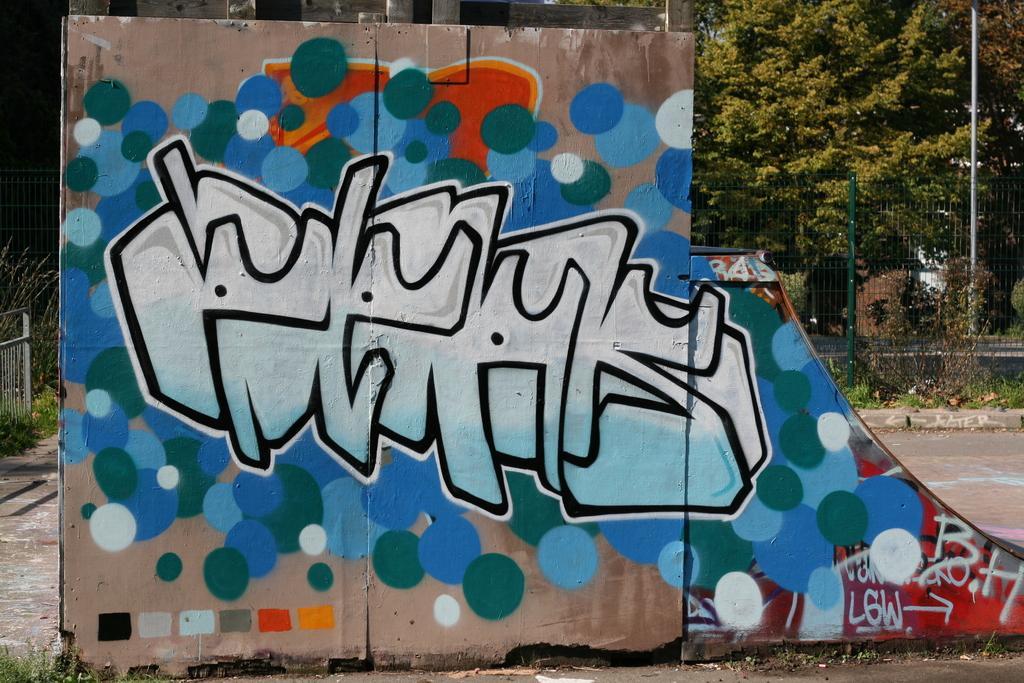Please provide a concise description of this image. In this image there is a wall. There are paintings and text on the wall. Behind the wall there is a fence. There is grass on the ground. In the background there are trees and a pole. 